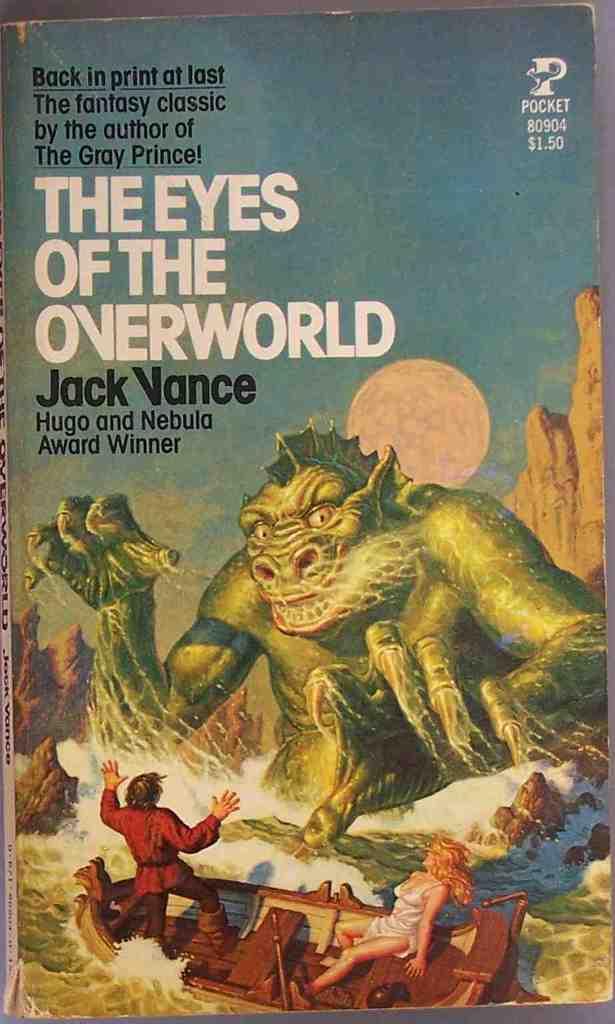What is the title of the book?
Provide a short and direct response. The eyes of the overworld. 